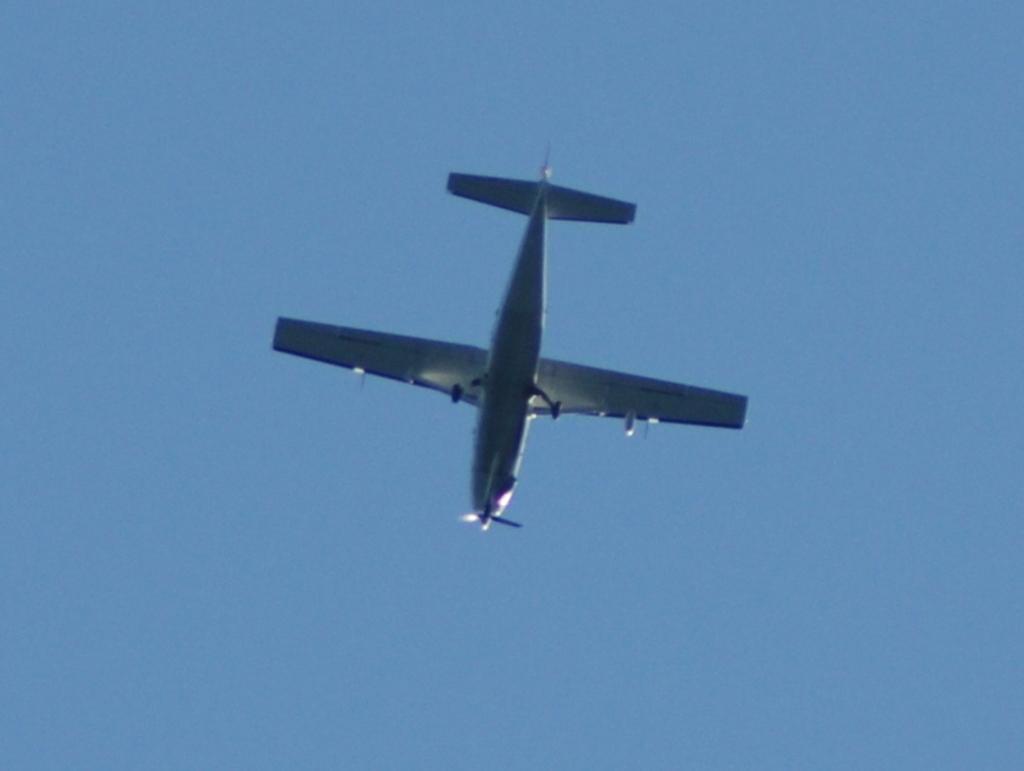How would you summarize this image in a sentence or two? Here the sky is blue and an aeroplane is flying in the sky. The aeroplane is in white color. 